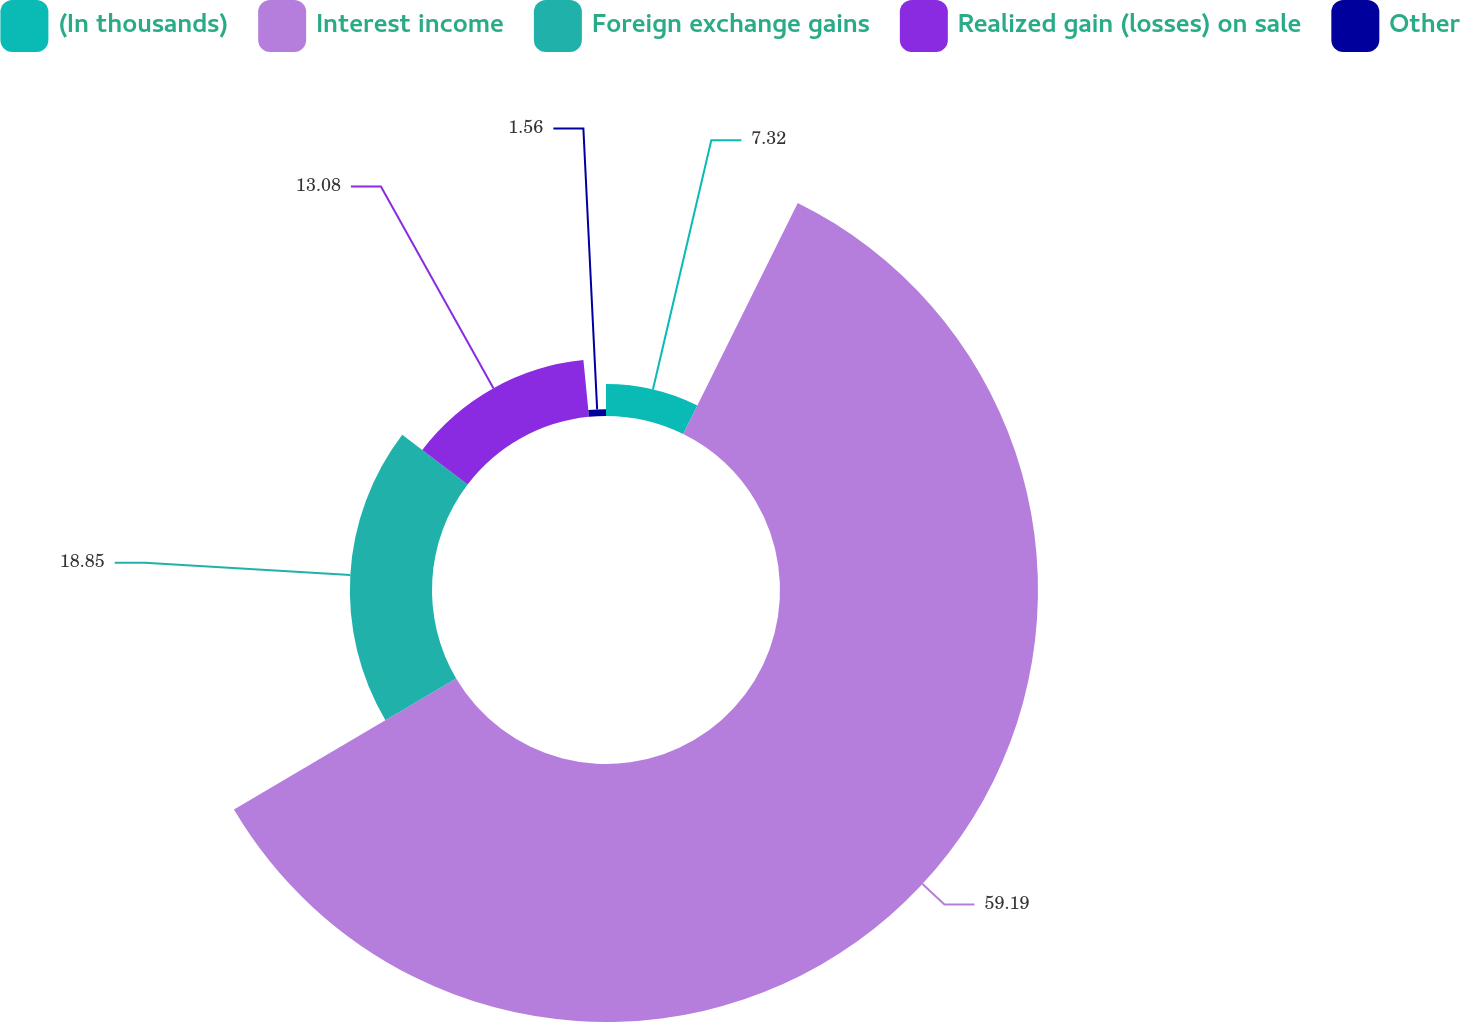<chart> <loc_0><loc_0><loc_500><loc_500><pie_chart><fcel>(In thousands)<fcel>Interest income<fcel>Foreign exchange gains<fcel>Realized gain (losses) on sale<fcel>Other<nl><fcel>7.32%<fcel>59.2%<fcel>18.85%<fcel>13.08%<fcel>1.56%<nl></chart> 